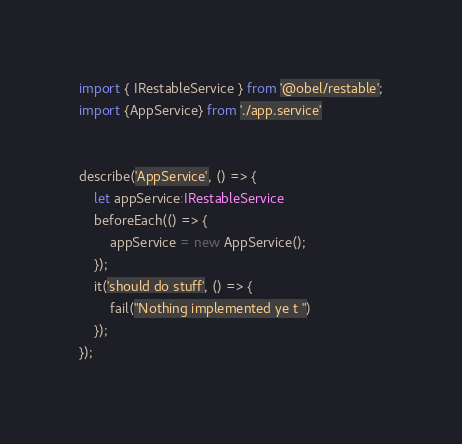<code> <loc_0><loc_0><loc_500><loc_500><_TypeScript_>import { IRestableService } from '@obel/restable';
import {AppService} from './app.service'


describe('AppService', () => {
    let appService:IRestableService
    beforeEach(() => {
        appService = new AppService();
    });
    it('should do stuff', () => {
        fail("Nothing implemented ye t ")
    });
});</code> 